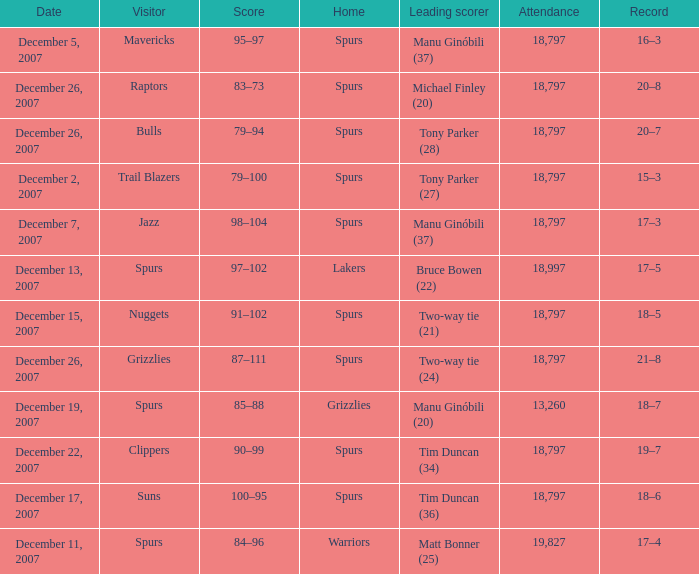Parse the full table. {'header': ['Date', 'Visitor', 'Score', 'Home', 'Leading scorer', 'Attendance', 'Record'], 'rows': [['December 5, 2007', 'Mavericks', '95–97', 'Spurs', 'Manu Ginóbili (37)', '18,797', '16–3'], ['December 26, 2007', 'Raptors', '83–73', 'Spurs', 'Michael Finley (20)', '18,797', '20–8'], ['December 26, 2007', 'Bulls', '79–94', 'Spurs', 'Tony Parker (28)', '18,797', '20–7'], ['December 2, 2007', 'Trail Blazers', '79–100', 'Spurs', 'Tony Parker (27)', '18,797', '15–3'], ['December 7, 2007', 'Jazz', '98–104', 'Spurs', 'Manu Ginóbili (37)', '18,797', '17–3'], ['December 13, 2007', 'Spurs', '97–102', 'Lakers', 'Bruce Bowen (22)', '18,997', '17–5'], ['December 15, 2007', 'Nuggets', '91–102', 'Spurs', 'Two-way tie (21)', '18,797', '18–5'], ['December 26, 2007', 'Grizzlies', '87–111', 'Spurs', 'Two-way tie (24)', '18,797', '21–8'], ['December 19, 2007', 'Spurs', '85–88', 'Grizzlies', 'Manu Ginóbili (20)', '13,260', '18–7'], ['December 22, 2007', 'Clippers', '90–99', 'Spurs', 'Tim Duncan (34)', '18,797', '19–7'], ['December 17, 2007', 'Suns', '100–95', 'Spurs', 'Tim Duncan (36)', '18,797', '18–6'], ['December 11, 2007', 'Spurs', '84–96', 'Warriors', 'Matt Bonner (25)', '19,827', '17–4']]} What is the record of the game on December 5, 2007? 16–3. 